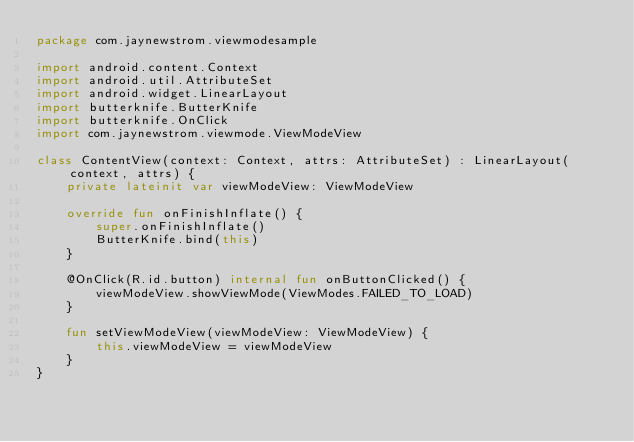<code> <loc_0><loc_0><loc_500><loc_500><_Kotlin_>package com.jaynewstrom.viewmodesample

import android.content.Context
import android.util.AttributeSet
import android.widget.LinearLayout
import butterknife.ButterKnife
import butterknife.OnClick
import com.jaynewstrom.viewmode.ViewModeView

class ContentView(context: Context, attrs: AttributeSet) : LinearLayout(context, attrs) {
    private lateinit var viewModeView: ViewModeView

    override fun onFinishInflate() {
        super.onFinishInflate()
        ButterKnife.bind(this)
    }

    @OnClick(R.id.button) internal fun onButtonClicked() {
        viewModeView.showViewMode(ViewModes.FAILED_TO_LOAD)
    }

    fun setViewModeView(viewModeView: ViewModeView) {
        this.viewModeView = viewModeView
    }
}
</code> 